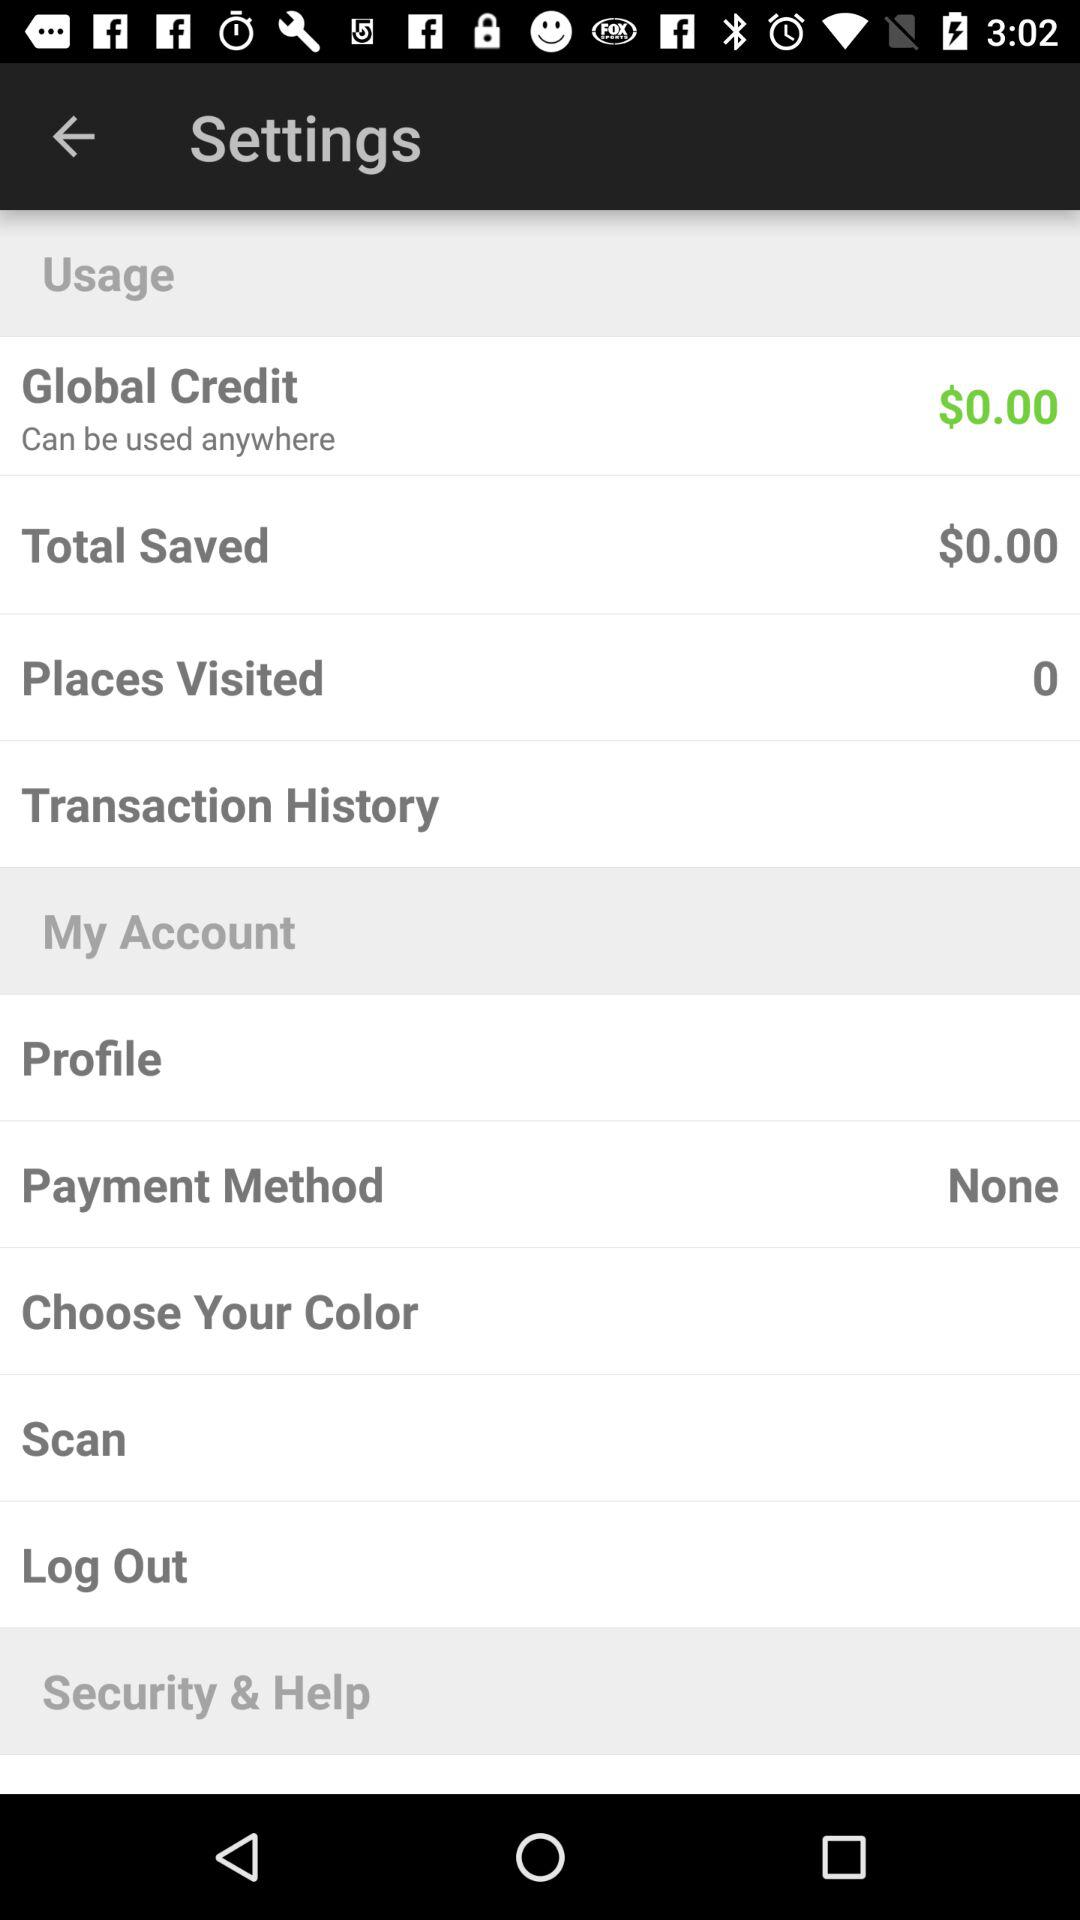How many places are visited? The number of places visited is 0. 